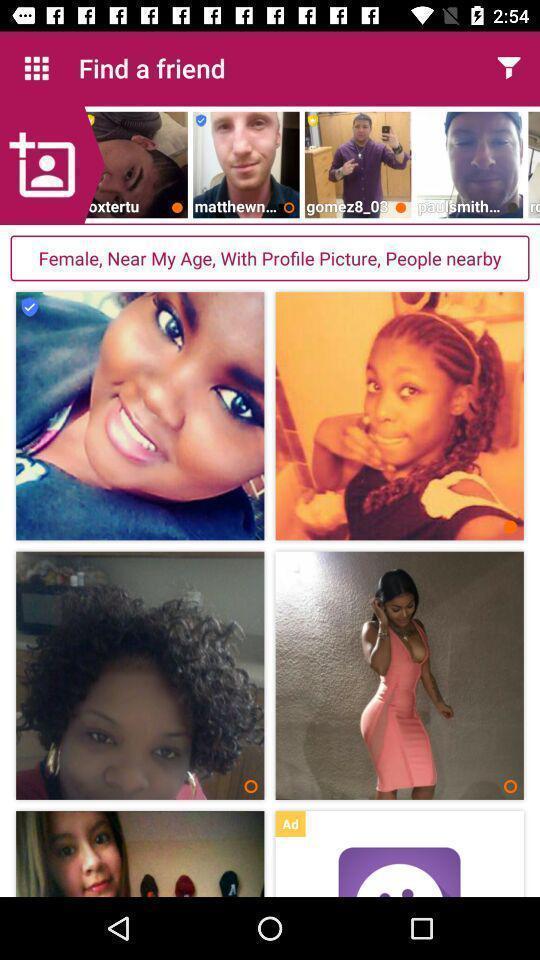Provide a textual representation of this image. Page showing content in a dating app. 